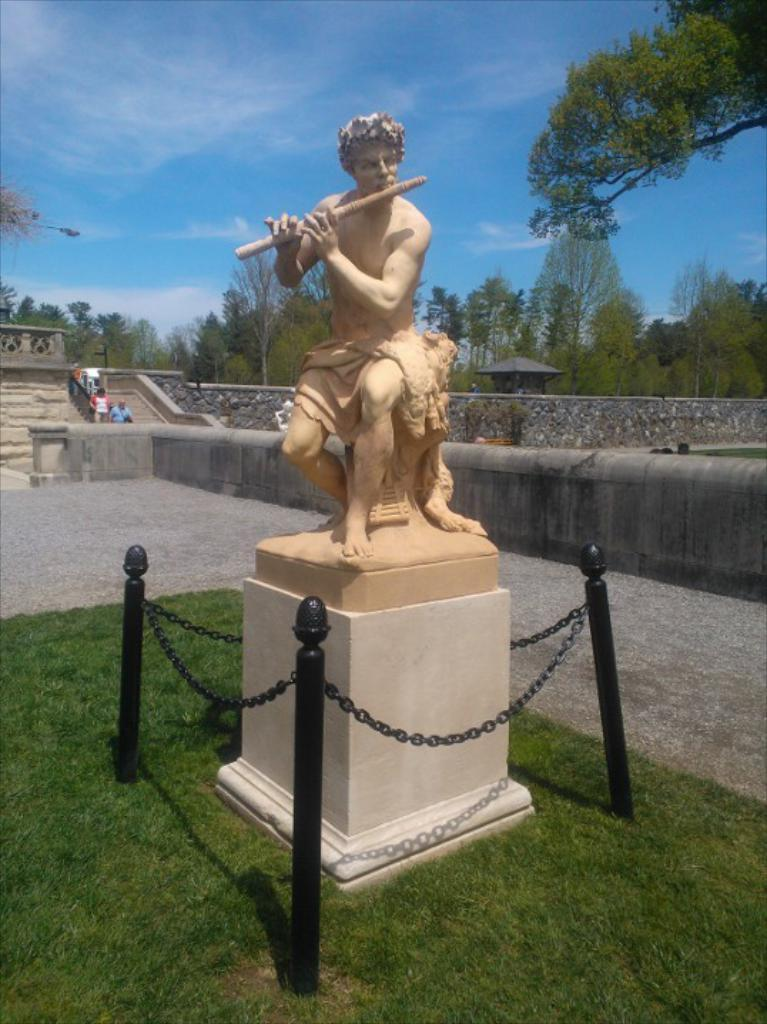What is the main subject of the image? There is a statue of a man in the image. What type of surface is under the statue? There is grass on the ground in the image. What can be seen happening in the background of the image? There are people walking in the background of the image. What is visible in the sky in the image? The sky is visible in the background of the image. What type of machine can be seen in the image? There is no machine present in the image; it features a statue of a man, grass, people walking, and a visible sky. Can you tell me how many patches are on the statue's clothing in the image? There is no mention of patches on the statue's clothing in the image; it only shows a statue of a man, grass, people walking, and a visible sky. 